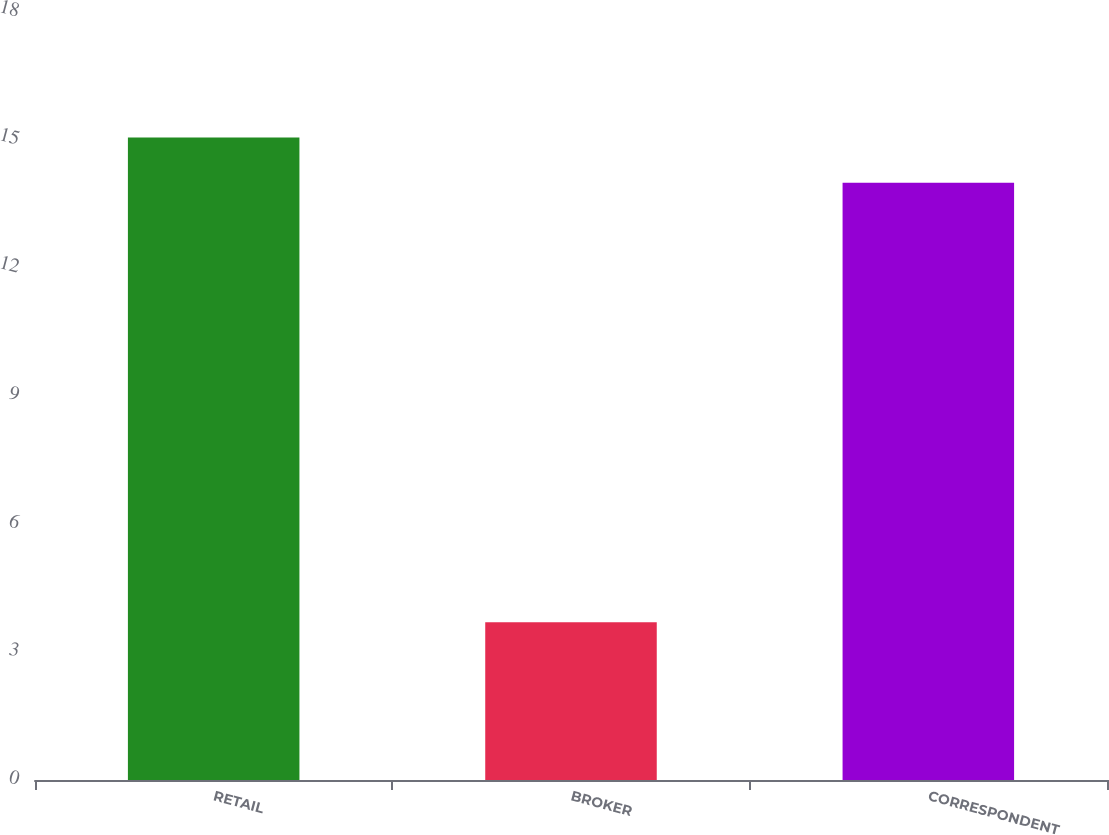Convert chart to OTSL. <chart><loc_0><loc_0><loc_500><loc_500><bar_chart><fcel>RETAIL<fcel>BROKER<fcel>CORRESPONDENT<nl><fcel>15.06<fcel>3.7<fcel>14<nl></chart> 